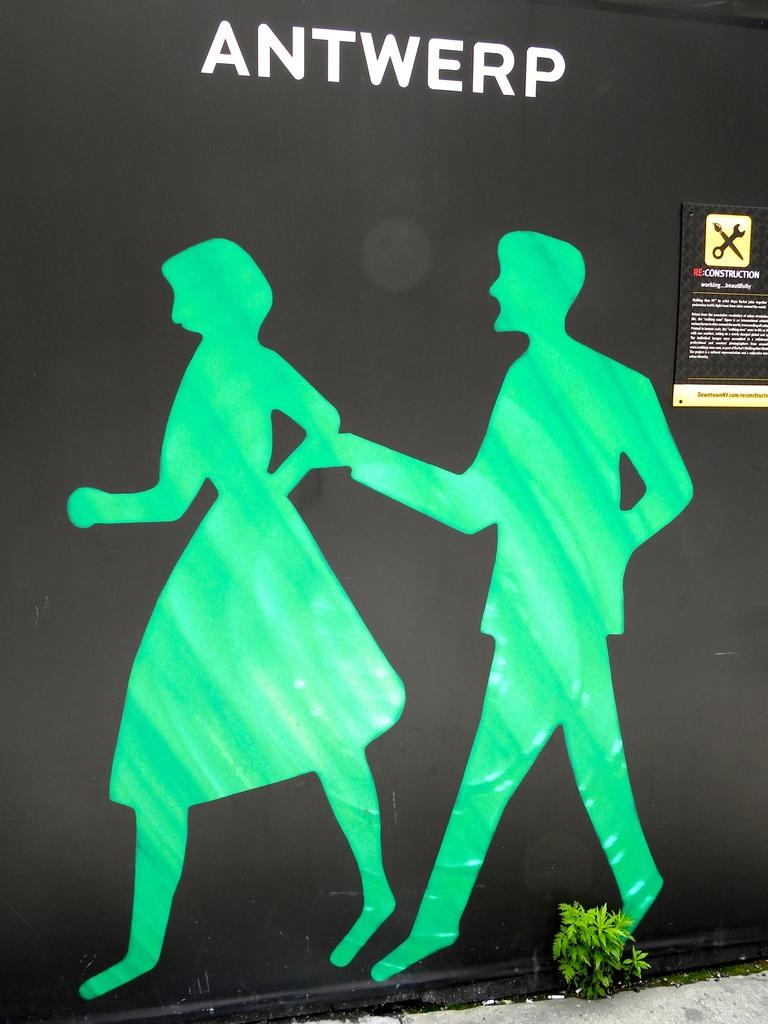<image>
Offer a succinct explanation of the picture presented. An image of a man and woman is titled with Antwerp. 